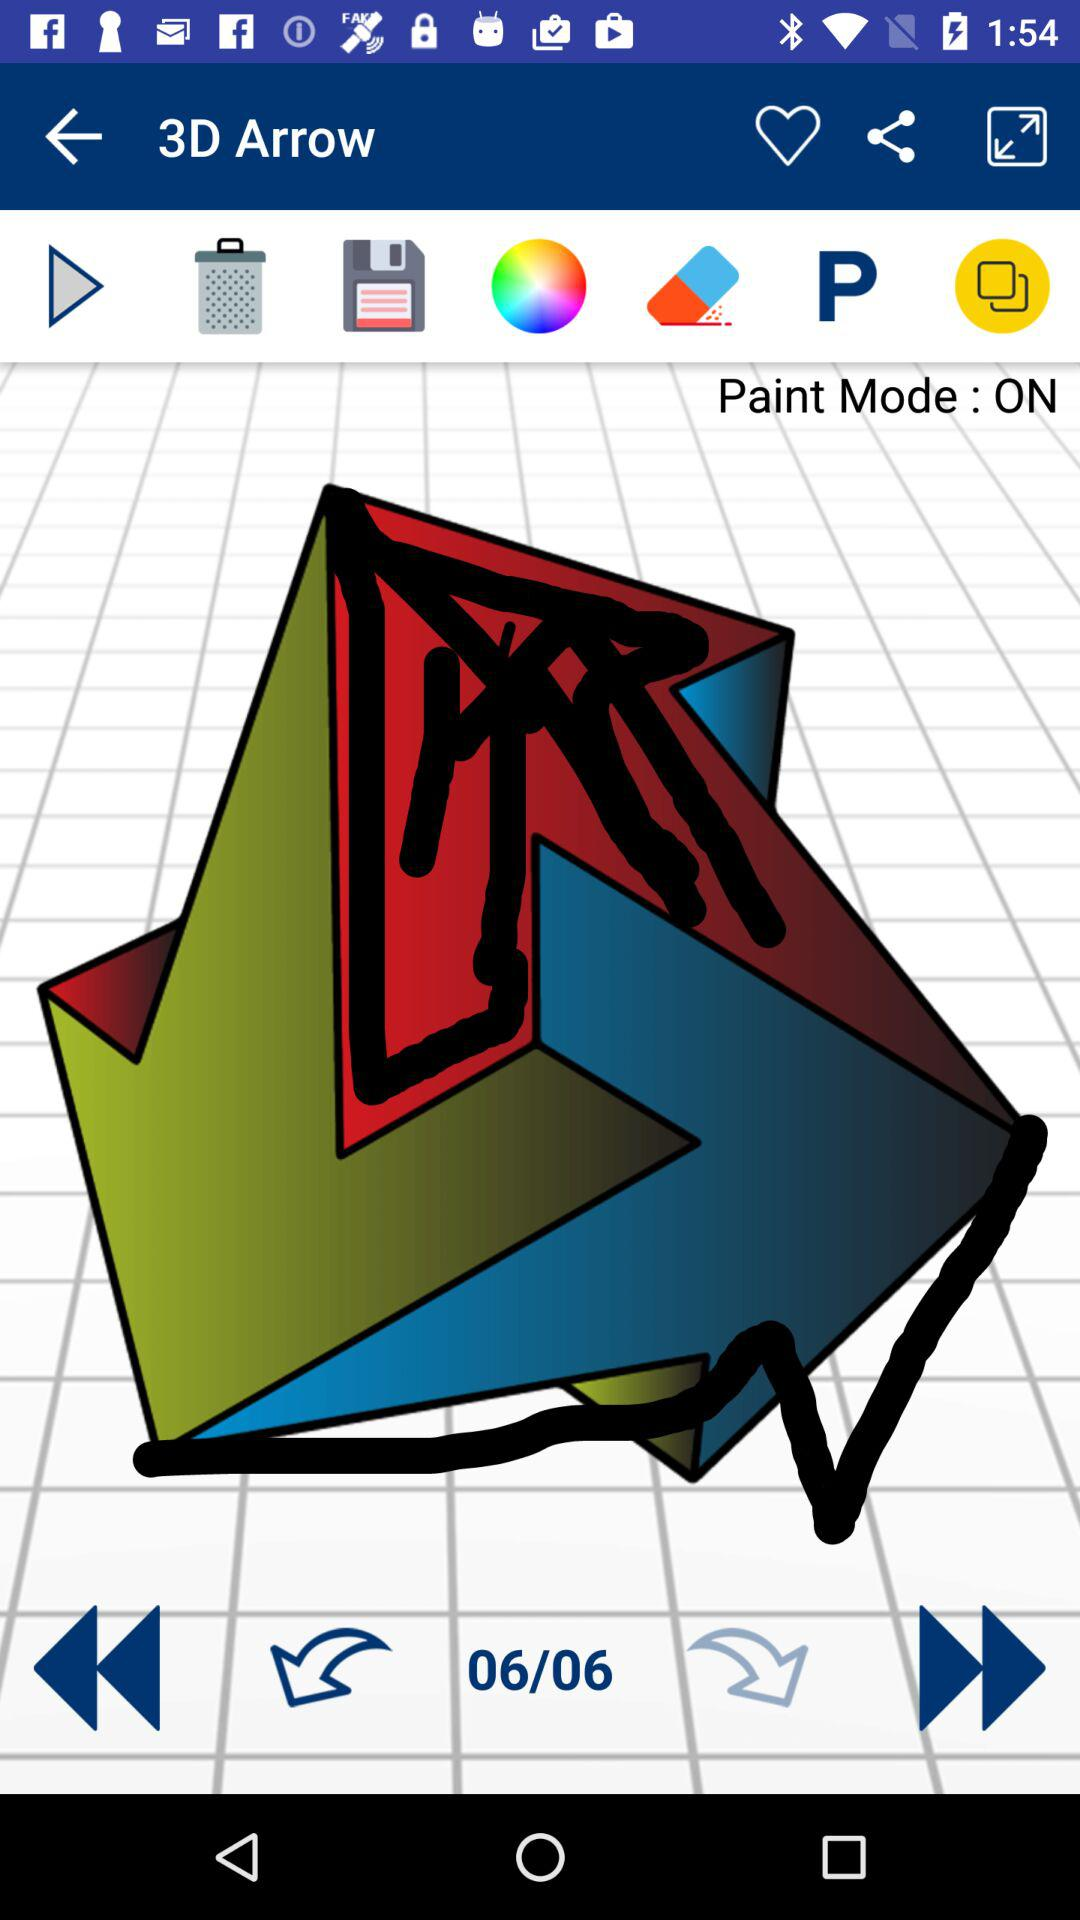What is the status of "Paint Mode"? "Paint Mode" is on. 